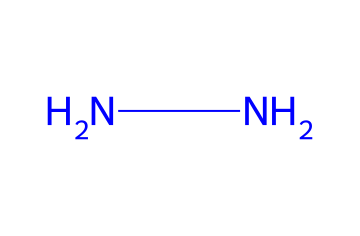What is the total number of nitrogen atoms in hydrazine? The SMILES representation 'NN' indicates that there are two nitrogen (N) atoms present in the molecule.
Answer: two How many bonds are formed between the nitrogen atoms in hydrazine? In the 'NN' structure, there is a single bond between the two nitrogen atoms, which indicates one bond.
Answer: one What is the molecular formula for hydrazine? Based on the two nitrogen atoms present in the SMILES 'NN', the molecular formula is N2H4, as hydrazine consists of four hydrogen atoms bonded to the two nitrogen atoms.
Answer: N2H4 Is hydrazine a base or an acid? Hydrazine is classified as a base because it has a lone pair of electrons on the nitrogen atoms, allowing it to accept protons.
Answer: base What type of chemical is hydrazine? Hydrazines, like the one represented by 'NN', are classified as nitrogen-based compounds known for their use as reducing agents and in rocket fuel.
Answer: nitrogen-based compound What characteristic of hydrazine contributes to its use in preserving inks? The presence of the nitrogen atoms in hydrazine contributes to its reducing properties, making it useful to prevent ink degradation over time.
Answer: reducing properties 